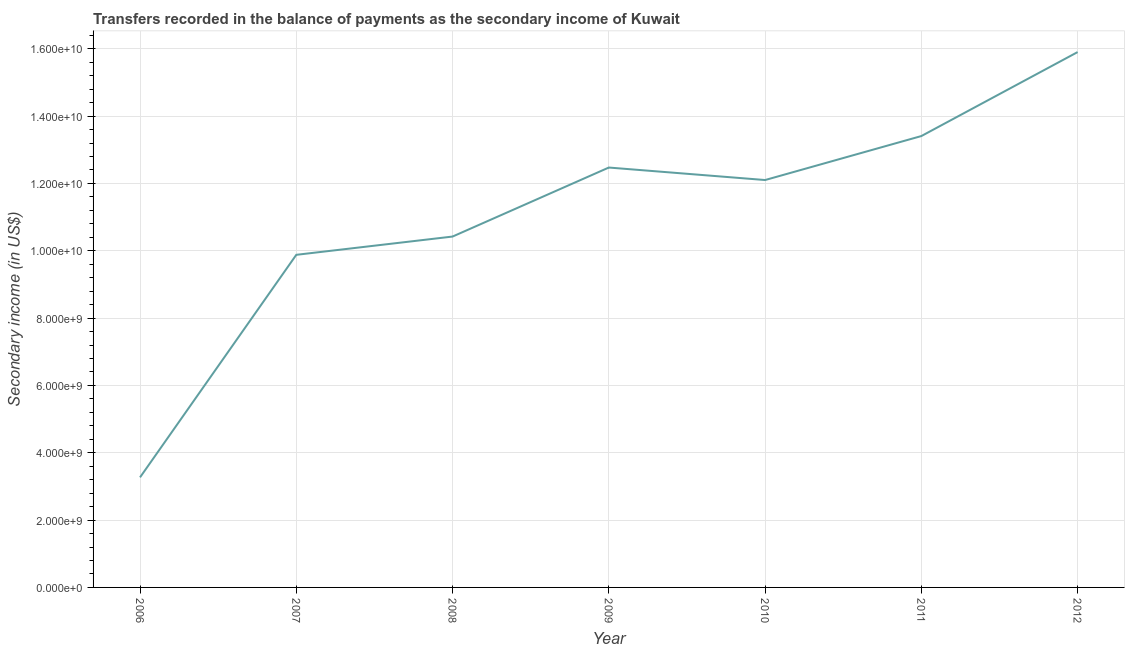What is the amount of secondary income in 2006?
Provide a succinct answer. 3.27e+09. Across all years, what is the maximum amount of secondary income?
Keep it short and to the point. 1.59e+1. Across all years, what is the minimum amount of secondary income?
Give a very brief answer. 3.27e+09. In which year was the amount of secondary income maximum?
Your answer should be compact. 2012. In which year was the amount of secondary income minimum?
Offer a terse response. 2006. What is the sum of the amount of secondary income?
Give a very brief answer. 7.75e+1. What is the difference between the amount of secondary income in 2009 and 2011?
Keep it short and to the point. -9.35e+08. What is the average amount of secondary income per year?
Offer a very short reply. 1.11e+1. What is the median amount of secondary income?
Your response must be concise. 1.21e+1. Do a majority of the years between 2006 and 2012 (inclusive) have amount of secondary income greater than 4800000000 US$?
Offer a terse response. Yes. What is the ratio of the amount of secondary income in 2006 to that in 2009?
Offer a very short reply. 0.26. Is the amount of secondary income in 2010 less than that in 2012?
Keep it short and to the point. Yes. What is the difference between the highest and the second highest amount of secondary income?
Give a very brief answer. 2.49e+09. What is the difference between the highest and the lowest amount of secondary income?
Your answer should be compact. 1.26e+1. Does the amount of secondary income monotonically increase over the years?
Your response must be concise. No. How many lines are there?
Make the answer very short. 1. Does the graph contain any zero values?
Your response must be concise. No. What is the title of the graph?
Ensure brevity in your answer.  Transfers recorded in the balance of payments as the secondary income of Kuwait. What is the label or title of the Y-axis?
Your answer should be compact. Secondary income (in US$). What is the Secondary income (in US$) in 2006?
Make the answer very short. 3.27e+09. What is the Secondary income (in US$) in 2007?
Provide a short and direct response. 9.88e+09. What is the Secondary income (in US$) in 2008?
Keep it short and to the point. 1.04e+1. What is the Secondary income (in US$) of 2009?
Make the answer very short. 1.25e+1. What is the Secondary income (in US$) of 2010?
Keep it short and to the point. 1.21e+1. What is the Secondary income (in US$) of 2011?
Your response must be concise. 1.34e+1. What is the Secondary income (in US$) in 2012?
Offer a terse response. 1.59e+1. What is the difference between the Secondary income (in US$) in 2006 and 2007?
Provide a short and direct response. -6.61e+09. What is the difference between the Secondary income (in US$) in 2006 and 2008?
Offer a terse response. -7.15e+09. What is the difference between the Secondary income (in US$) in 2006 and 2009?
Keep it short and to the point. -9.20e+09. What is the difference between the Secondary income (in US$) in 2006 and 2010?
Keep it short and to the point. -8.83e+09. What is the difference between the Secondary income (in US$) in 2006 and 2011?
Your response must be concise. -1.01e+1. What is the difference between the Secondary income (in US$) in 2006 and 2012?
Make the answer very short. -1.26e+1. What is the difference between the Secondary income (in US$) in 2007 and 2008?
Offer a very short reply. -5.42e+08. What is the difference between the Secondary income (in US$) in 2007 and 2009?
Offer a terse response. -2.59e+09. What is the difference between the Secondary income (in US$) in 2007 and 2010?
Offer a terse response. -2.22e+09. What is the difference between the Secondary income (in US$) in 2007 and 2011?
Offer a terse response. -3.53e+09. What is the difference between the Secondary income (in US$) in 2007 and 2012?
Offer a terse response. -6.02e+09. What is the difference between the Secondary income (in US$) in 2008 and 2009?
Make the answer very short. -2.05e+09. What is the difference between the Secondary income (in US$) in 2008 and 2010?
Ensure brevity in your answer.  -1.68e+09. What is the difference between the Secondary income (in US$) in 2008 and 2011?
Offer a very short reply. -2.99e+09. What is the difference between the Secondary income (in US$) in 2008 and 2012?
Offer a very short reply. -5.48e+09. What is the difference between the Secondary income (in US$) in 2009 and 2010?
Your response must be concise. 3.71e+08. What is the difference between the Secondary income (in US$) in 2009 and 2011?
Offer a terse response. -9.35e+08. What is the difference between the Secondary income (in US$) in 2009 and 2012?
Provide a succinct answer. -3.43e+09. What is the difference between the Secondary income (in US$) in 2010 and 2011?
Offer a very short reply. -1.31e+09. What is the difference between the Secondary income (in US$) in 2010 and 2012?
Your response must be concise. -3.80e+09. What is the difference between the Secondary income (in US$) in 2011 and 2012?
Offer a very short reply. -2.49e+09. What is the ratio of the Secondary income (in US$) in 2006 to that in 2007?
Ensure brevity in your answer.  0.33. What is the ratio of the Secondary income (in US$) in 2006 to that in 2008?
Your response must be concise. 0.31. What is the ratio of the Secondary income (in US$) in 2006 to that in 2009?
Provide a succinct answer. 0.26. What is the ratio of the Secondary income (in US$) in 2006 to that in 2010?
Offer a very short reply. 0.27. What is the ratio of the Secondary income (in US$) in 2006 to that in 2011?
Your answer should be compact. 0.24. What is the ratio of the Secondary income (in US$) in 2006 to that in 2012?
Your answer should be compact. 0.21. What is the ratio of the Secondary income (in US$) in 2007 to that in 2008?
Make the answer very short. 0.95. What is the ratio of the Secondary income (in US$) in 2007 to that in 2009?
Offer a terse response. 0.79. What is the ratio of the Secondary income (in US$) in 2007 to that in 2010?
Offer a very short reply. 0.82. What is the ratio of the Secondary income (in US$) in 2007 to that in 2011?
Offer a very short reply. 0.74. What is the ratio of the Secondary income (in US$) in 2007 to that in 2012?
Your response must be concise. 0.62. What is the ratio of the Secondary income (in US$) in 2008 to that in 2009?
Make the answer very short. 0.84. What is the ratio of the Secondary income (in US$) in 2008 to that in 2010?
Your answer should be compact. 0.86. What is the ratio of the Secondary income (in US$) in 2008 to that in 2011?
Your answer should be compact. 0.78. What is the ratio of the Secondary income (in US$) in 2008 to that in 2012?
Offer a very short reply. 0.66. What is the ratio of the Secondary income (in US$) in 2009 to that in 2010?
Ensure brevity in your answer.  1.03. What is the ratio of the Secondary income (in US$) in 2009 to that in 2011?
Offer a very short reply. 0.93. What is the ratio of the Secondary income (in US$) in 2009 to that in 2012?
Give a very brief answer. 0.78. What is the ratio of the Secondary income (in US$) in 2010 to that in 2011?
Make the answer very short. 0.9. What is the ratio of the Secondary income (in US$) in 2010 to that in 2012?
Provide a short and direct response. 0.76. What is the ratio of the Secondary income (in US$) in 2011 to that in 2012?
Make the answer very short. 0.84. 